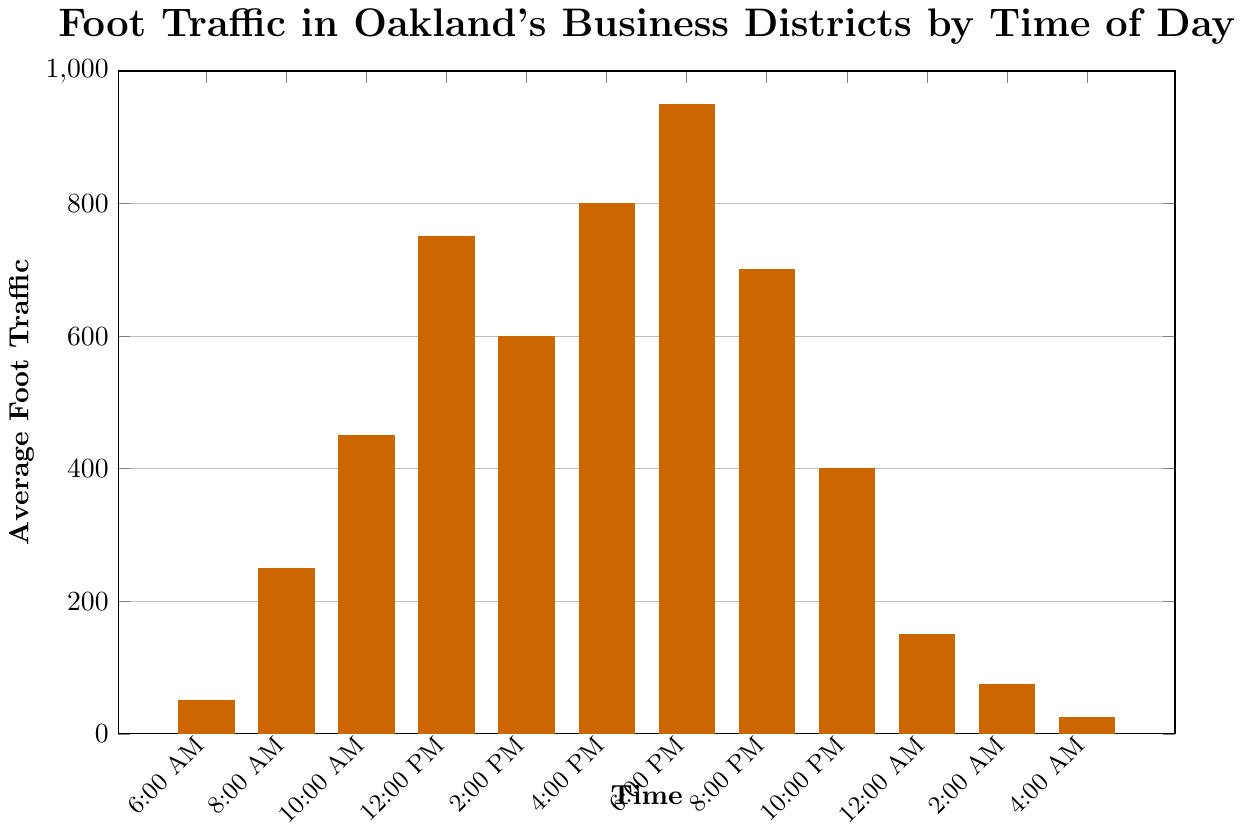what time experiences the highest average foot traffic? The highest bar in the chart represents the time slot with the highest average foot traffic. The bar for 6:00 PM reaches 950, which is higher than any other time slot.
Answer: 6:00 PM What is the difference in foot traffic between 6:00 PM and 8:00 PM? The bar for 6:00 PM shows 950, while the bar for 8:00 PM shows 700. The difference is obtained by subtracting the foot traffic at 8:00 PM from the foot traffic at 6:00 PM. 950 - 700 = 250.
Answer: 250 How does the average foot traffic at 10:00 AM compare to 2:00 PM? The bar for 10:00 AM shows 450 and for 2:00 PM it shows 600. Comparing these, 2:00 PM has higher foot traffic than 10:00 AM by 150 (600 - 450).
Answer: 2:00 PM has 150 more What is the total foot traffic from 6:00 AM to 12:00 PM? Summing up the foot traffic values from 6:00 AM (50), 8:00 AM (250), 10:00 AM (450), and 12:00 PM (750) gives 50 + 250 + 450 + 750 = 1500.
Answer: 1500 At which time does foot traffic drop below 100 for the first time? Observing the chart sequentially, the time slot wherein the bars first drop below the 100 mark is at 4:00 AM with a value of 25.
Answer: 4:00 AM Which time slots have more than 500 average foot traffic? Bars higher than the 500 mark represent these time slots. The bars for 12:00 PM (750), 4:00 PM (800), and 6:00 PM (950) reflect this.
Answer: 12:00 PM, 4:00 PM, 6:00 PM What is the sum of foot traffic from 10:00 PM to 4:00 AM? Adding the traffic values for 10:00 PM (400), 12:00 AM (150), 2:00 AM (75), and 4:00 AM (25) yields 400 + 150 + 75 + 25 = 650.
Answer: 650 Compare the foot traffic between 8:00 AM and 4:00 PM. Which one is higher and by how much? The 8:00 AM slot has a value of 250 and 4:00 PM has 800. Subtracting these, 4:00 PM is higher by 800 - 250 = 550.
Answer: 4:00 PM is higher by 550 What is the average foot traffic for the time slots between 12:00 AM and 4:00 AM? The times are 12:00 AM (150), 2:00 AM (75), 4:00 AM (25). Summing these gives 150 + 75 + 25 = 250. Dividing by the number of slots (3), the average is 250 / 3 ≈ 83.33.
Answer: ~83.33 What time period sees a rapid increase in foot traffic? Observing the bar heights, there is a rapid increase between 6:00 AM (50) and 8:00 AM (250), which is a 200-unit change.
Answer: 6:00 AM to 8:00 AM 